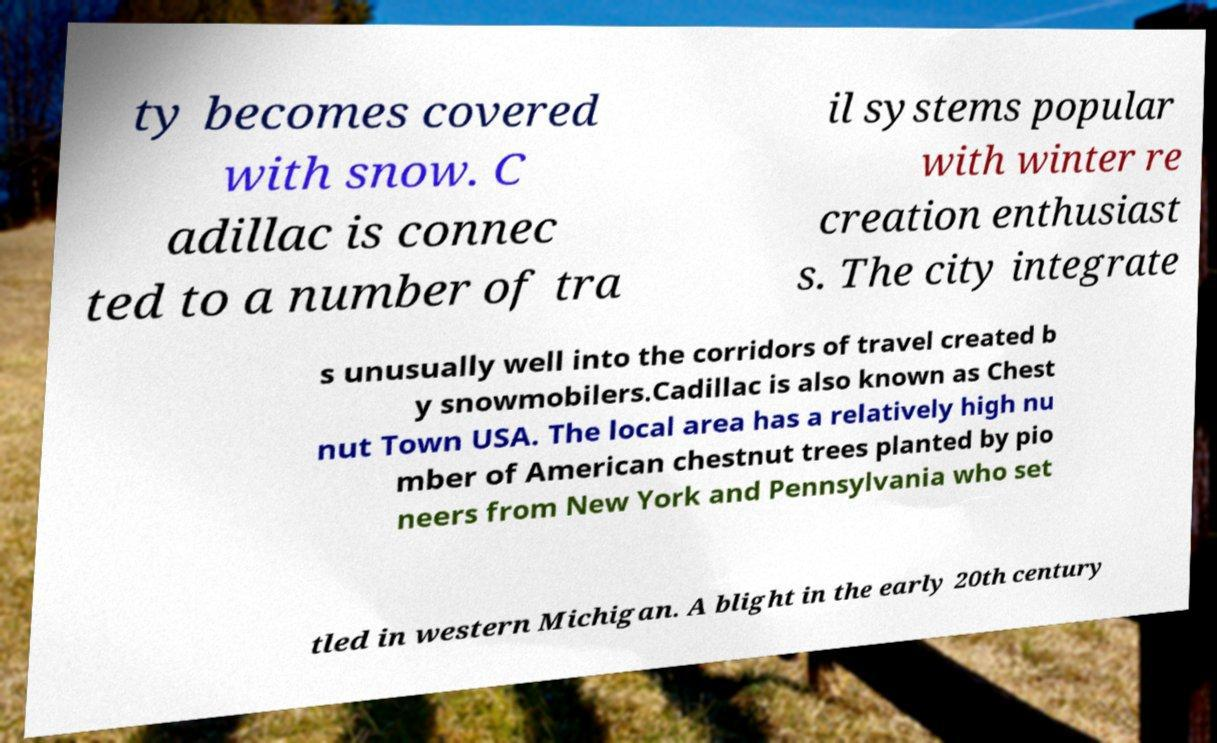I need the written content from this picture converted into text. Can you do that? ty becomes covered with snow. C adillac is connec ted to a number of tra il systems popular with winter re creation enthusiast s. The city integrate s unusually well into the corridors of travel created b y snowmobilers.Cadillac is also known as Chest nut Town USA. The local area has a relatively high nu mber of American chestnut trees planted by pio neers from New York and Pennsylvania who set tled in western Michigan. A blight in the early 20th century 